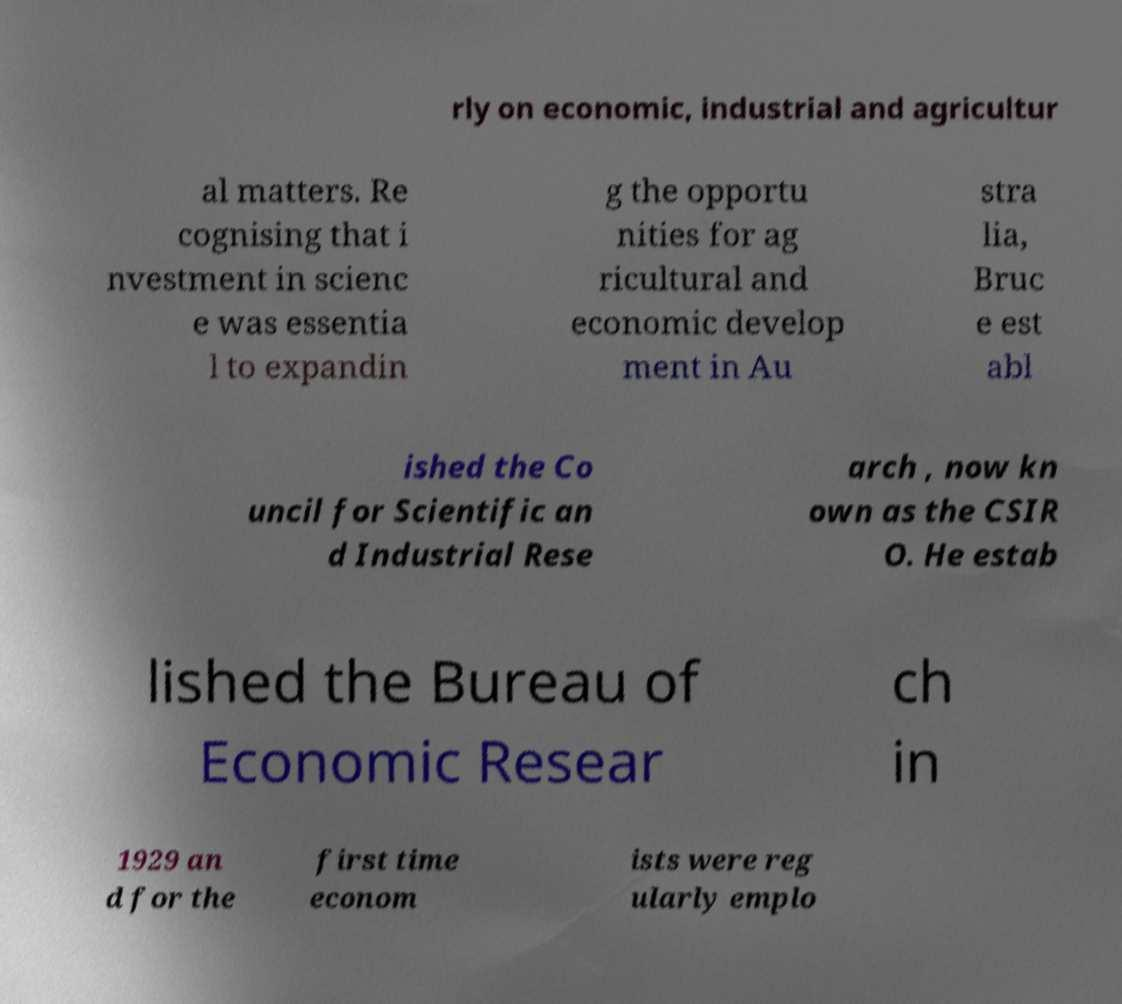Can you read and provide the text displayed in the image?This photo seems to have some interesting text. Can you extract and type it out for me? rly on economic, industrial and agricultur al matters. Re cognising that i nvestment in scienc e was essentia l to expandin g the opportu nities for ag ricultural and economic develop ment in Au stra lia, Bruc e est abl ished the Co uncil for Scientific an d Industrial Rese arch , now kn own as the CSIR O. He estab lished the Bureau of Economic Resear ch in 1929 an d for the first time econom ists were reg ularly emplo 